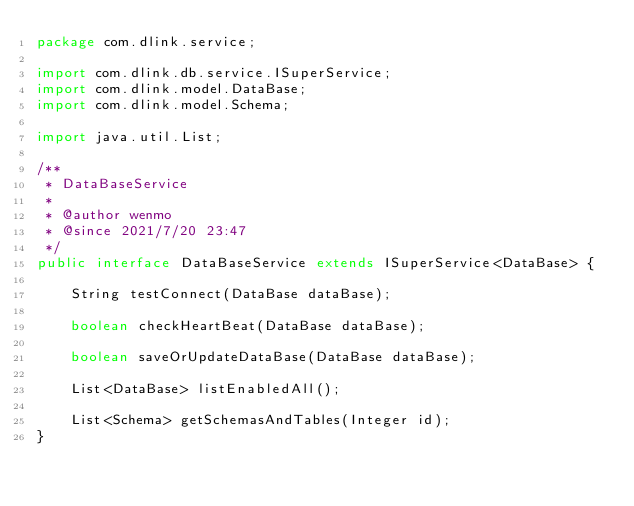<code> <loc_0><loc_0><loc_500><loc_500><_Java_>package com.dlink.service;

import com.dlink.db.service.ISuperService;
import com.dlink.model.DataBase;
import com.dlink.model.Schema;

import java.util.List;

/**
 * DataBaseService
 *
 * @author wenmo
 * @since 2021/7/20 23:47
 */
public interface DataBaseService extends ISuperService<DataBase> {

    String testConnect(DataBase dataBase);

    boolean checkHeartBeat(DataBase dataBase);

    boolean saveOrUpdateDataBase(DataBase dataBase);

    List<DataBase> listEnabledAll();

    List<Schema> getSchemasAndTables(Integer id);
}
</code> 